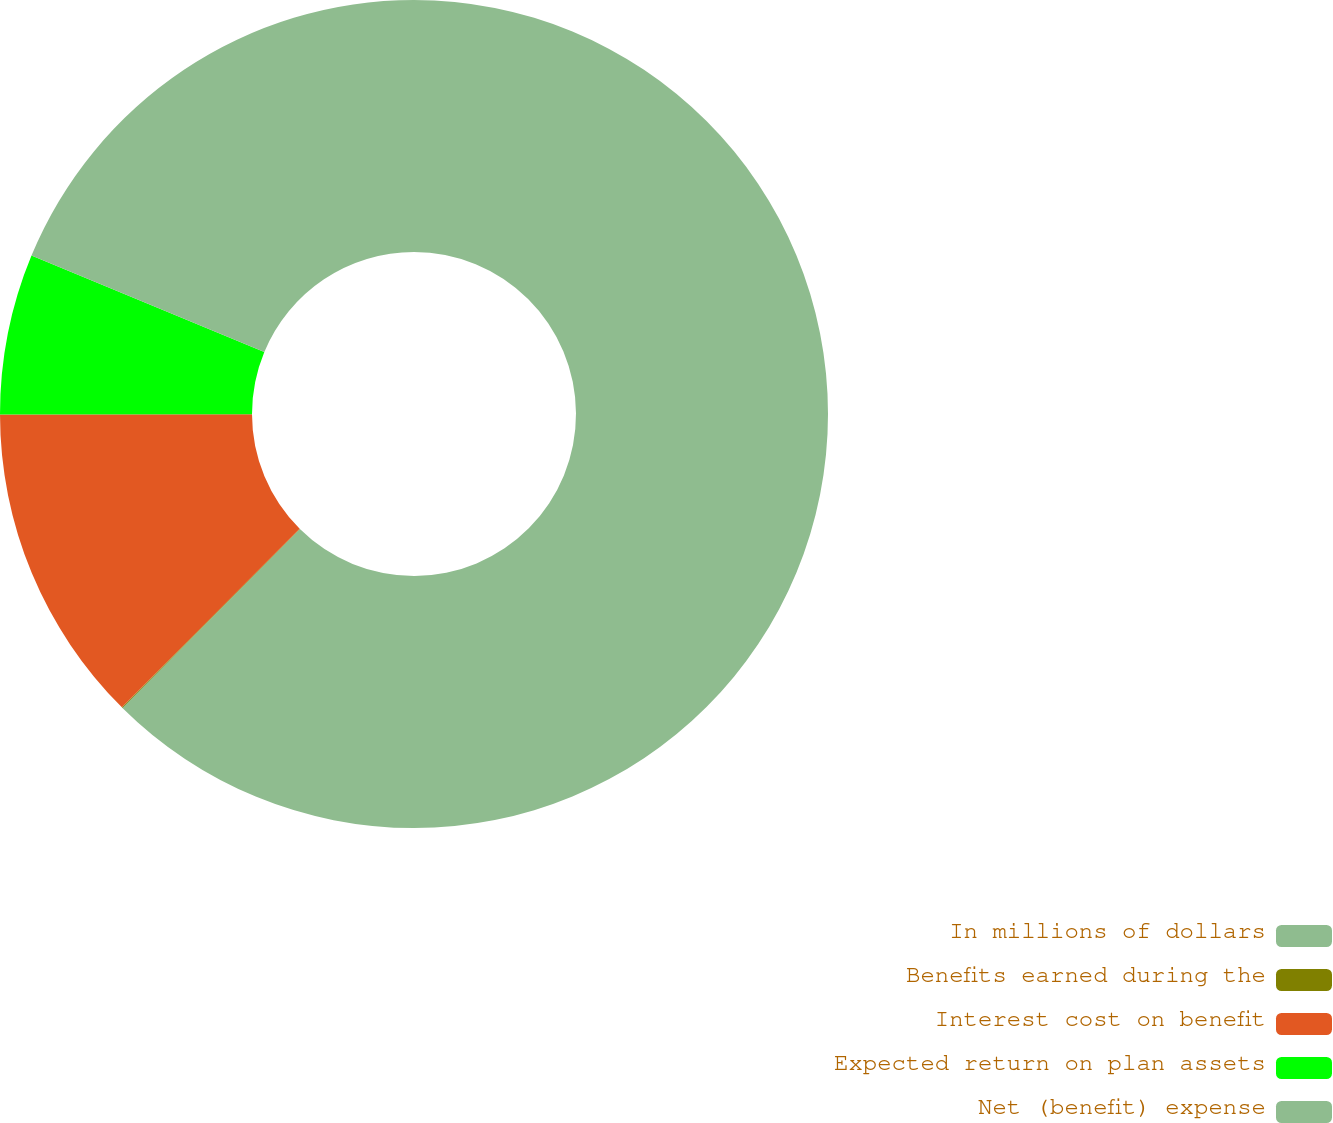<chart> <loc_0><loc_0><loc_500><loc_500><pie_chart><fcel>In millions of dollars<fcel>Benefits earned during the<fcel>Interest cost on benefit<fcel>Expected return on plan assets<fcel>Net (benefit) expense<nl><fcel>62.43%<fcel>0.03%<fcel>12.51%<fcel>6.27%<fcel>18.75%<nl></chart> 